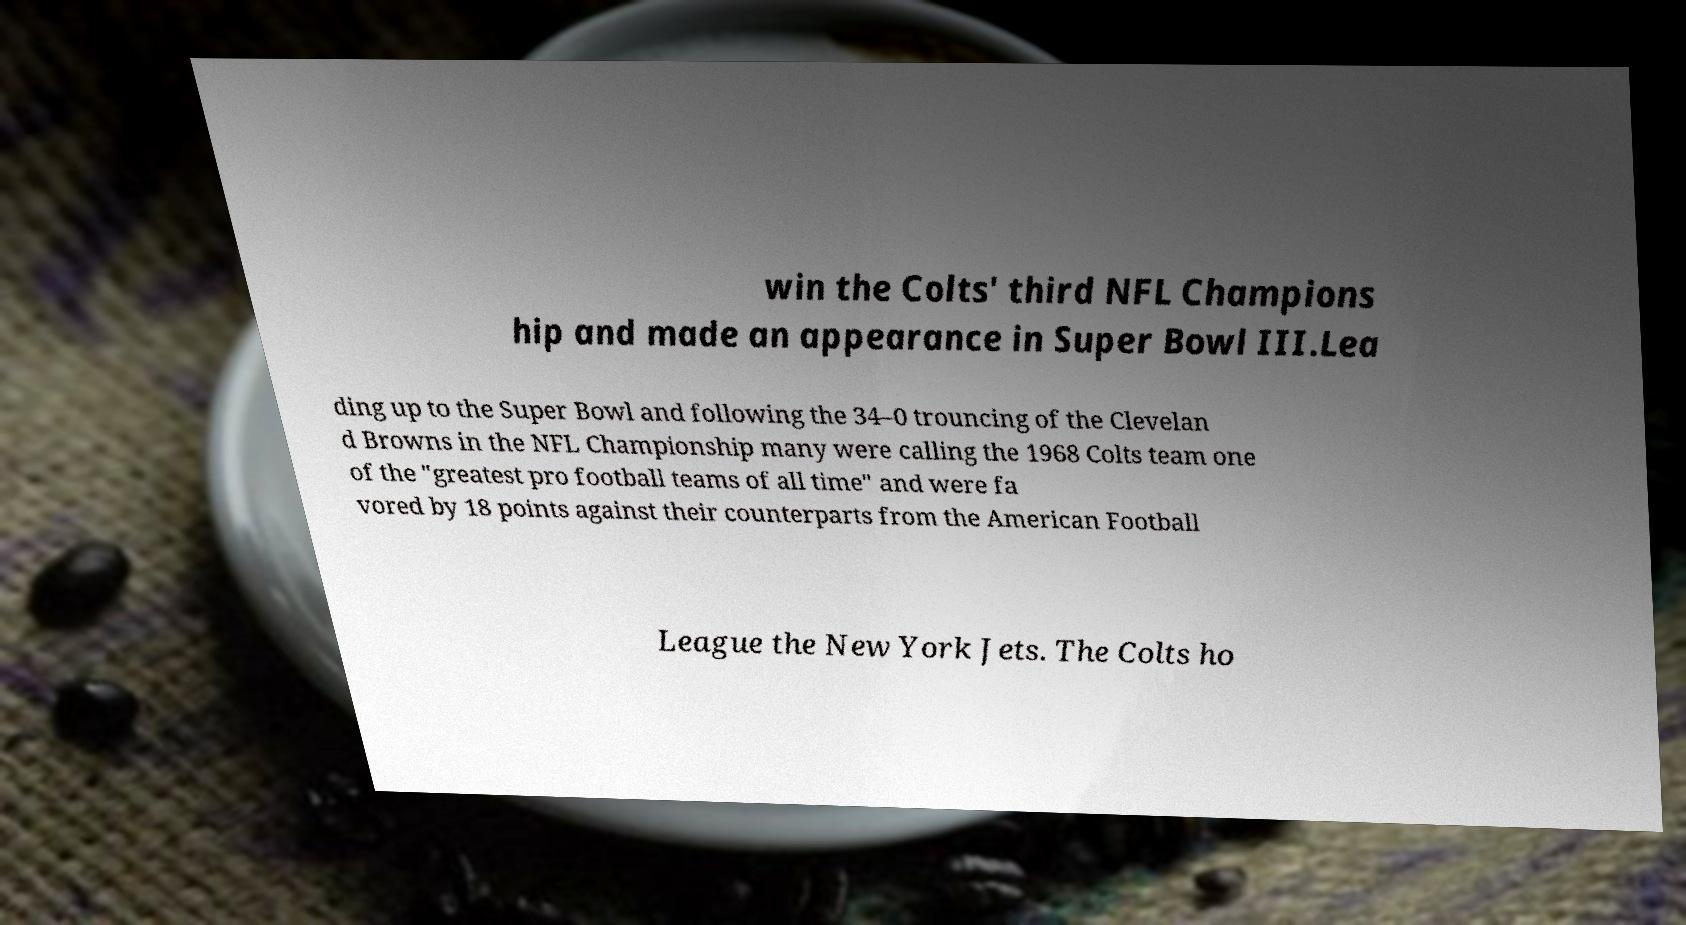There's text embedded in this image that I need extracted. Can you transcribe it verbatim? win the Colts' third NFL Champions hip and made an appearance in Super Bowl III.Lea ding up to the Super Bowl and following the 34–0 trouncing of the Clevelan d Browns in the NFL Championship many were calling the 1968 Colts team one of the "greatest pro football teams of all time" and were fa vored by 18 points against their counterparts from the American Football League the New York Jets. The Colts ho 